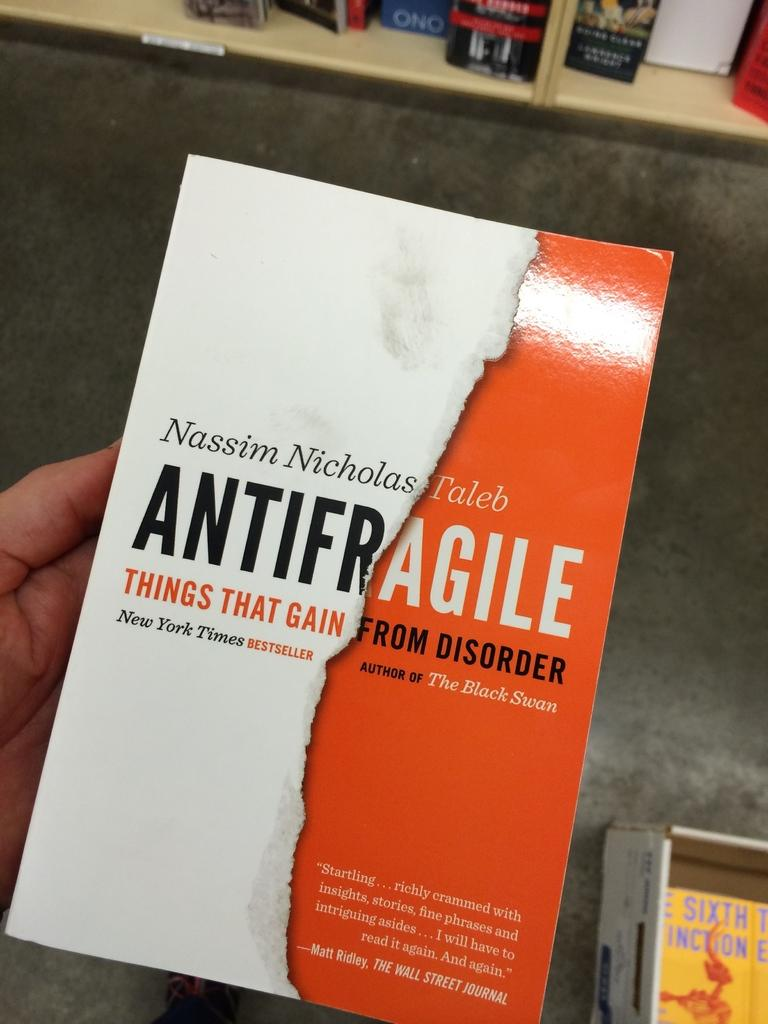<image>
Present a compact description of the photo's key features. An orange and white cover for the book Antifragile. 